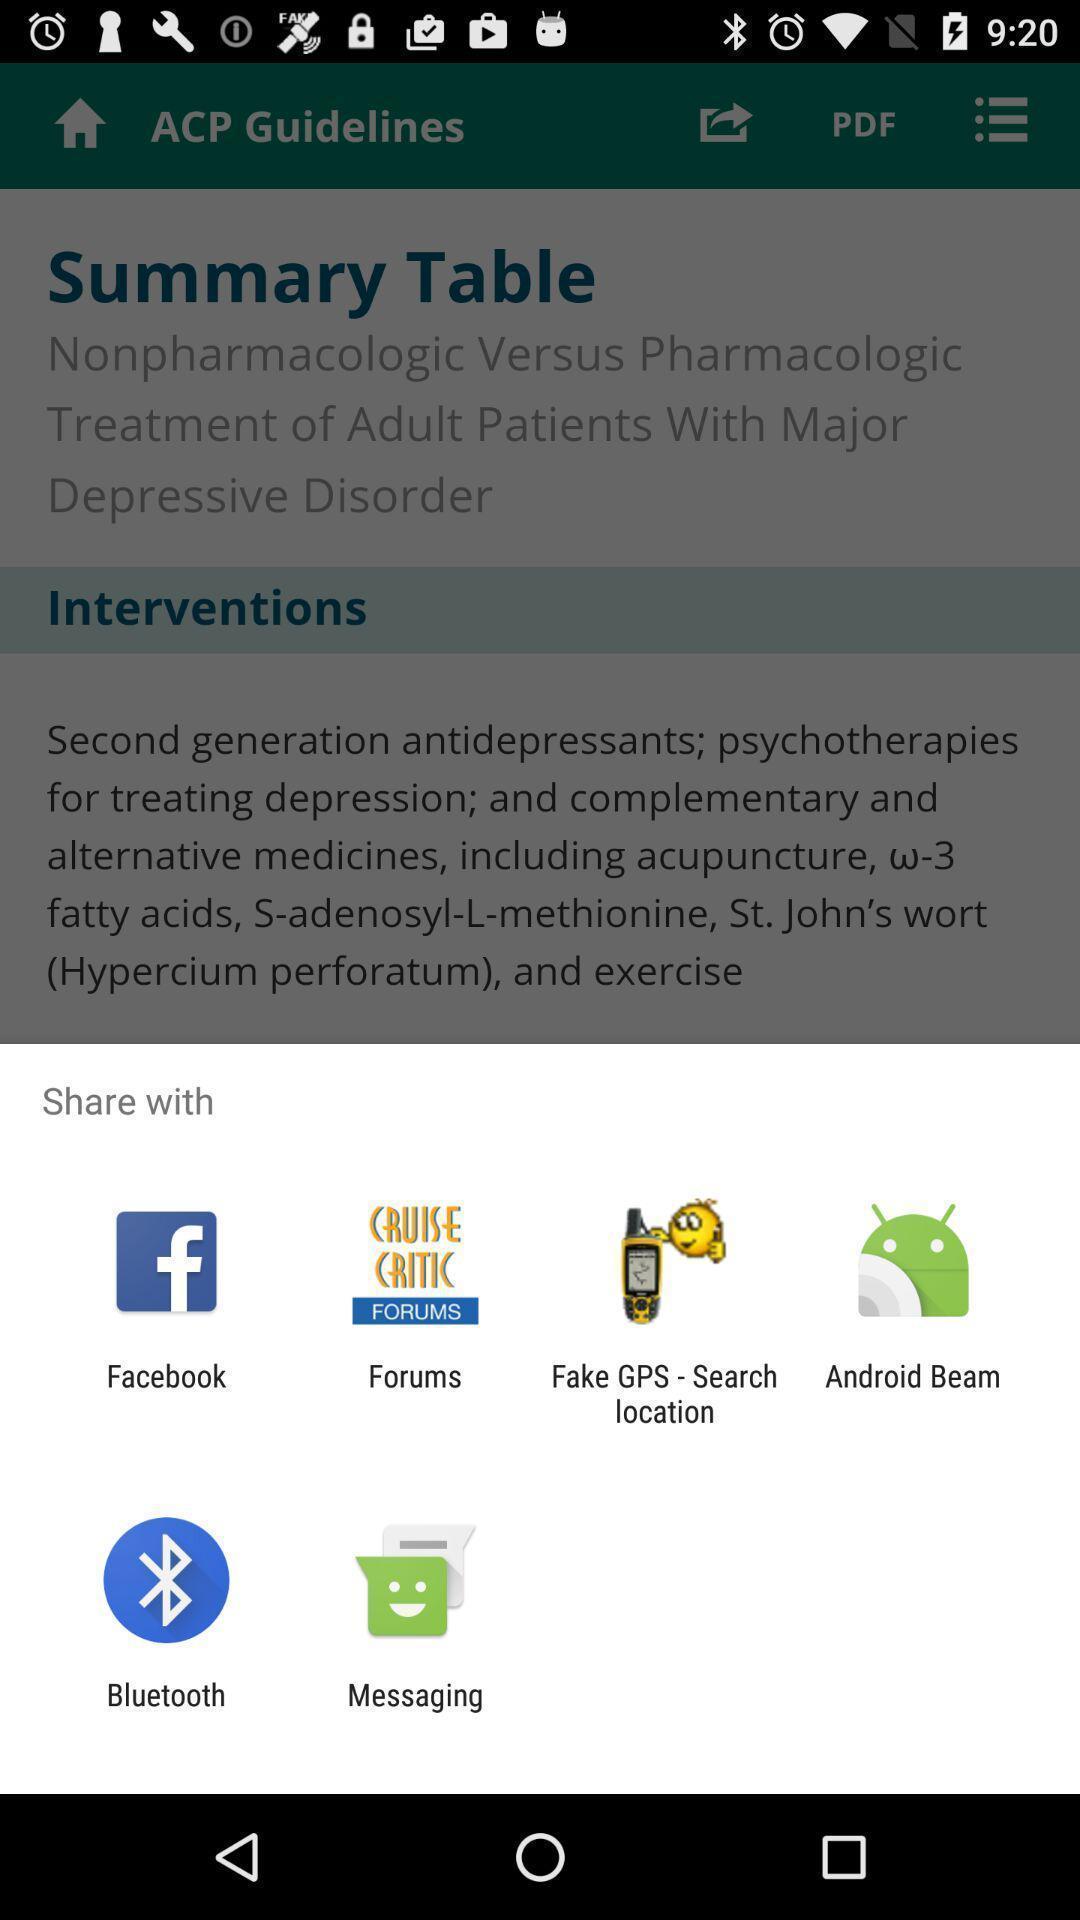Describe the content in this image. Screen showing various applications to share. 